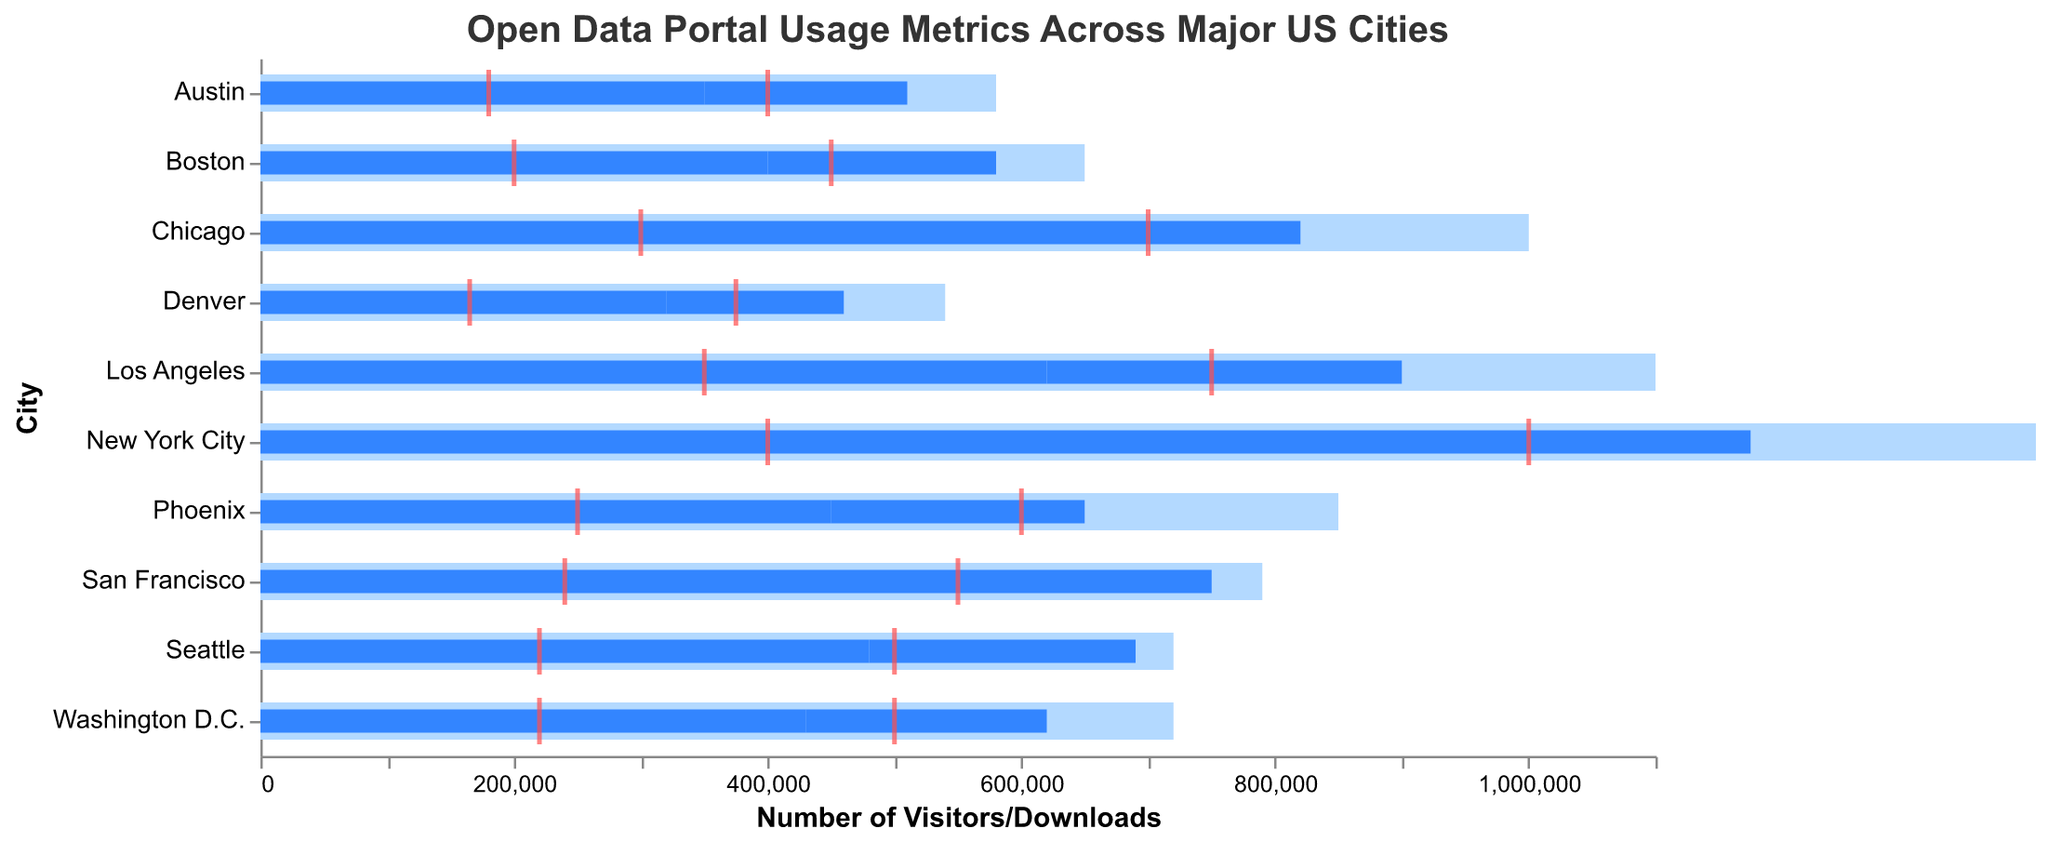What's the title of the figure? The title is usually placed at the top of the figure, and it provides a general idea of what the chart is about. In this case, it's "Open Data Portal Usage Metrics Across Major US Cities".
Answer: Open Data Portal Usage Metrics Across Major US Cities Which city has the highest number of visitors? By looking at the figure, the city with the longest blue bar representing visitors will have the highest number. In this chart, New York City has the highest number at 850,000.
Answer: New York City How many cities are represented in the chart? The number of cities can be counted by looking at the y-axis labels. The y-axis lists the cities from New York City to Denver, and counting them totals ten cities.
Answer: 10 What is the target number of downloads for Phoenix? To find the target number of downloads for Phoenix, look for the red tick mark on the horizontal axis corresponding to Phoenix. The target is 250,000 downloads.
Answer: 250,000 What's the difference between the actual and target number of visitors for Los Angeles? For Los Angeles, the actual number of visitors is 620,000, and the target is 750,000. Subtract the actual number from the target to get the difference: 750,000 - 620,000 = 130,000.
Answer: 130,000 Which city is closest to its target number of visitors? To find the city nearest to its visitor target, look at the blue bars and see which one comes closest to the end of the light blue bars. San Francisco has 520,000 visitors, very close to its 550,000 target.
Answer: San Francisco Compare the number of downloads between Austin and Boston. Which city has more? The actual number of downloads for Austin is 160,000, and for Boston, it is 180,000. Since 180,000 is greater than 160,000, Boston has more downloads.
Answer: Boston How many cities have visitors that exceed half of their target number? To determine this, check if more than half of the targeted visitors are attained in each city by comparing the blue bars with half of the light blue bar for the target. Cities meeting this criterion are New York City, Los Angeles, Chicago, Phoenix, San Francisco, Seattle, and Washington D.C., totaling seven cities.
Answer: 7 What is the average number of downloads across all cities? Add up the actual number of downloads for all cities (325,000 + 280,000 + 240,000 + 200,000 + 230,000 + 210,000 + 180,000 + 190,000 + 160,000 + 140,000 = 2,155,000) and divide by the number of cities (10). So, 2,155,000 / 10 = 215,500.
Answer: 215,500 